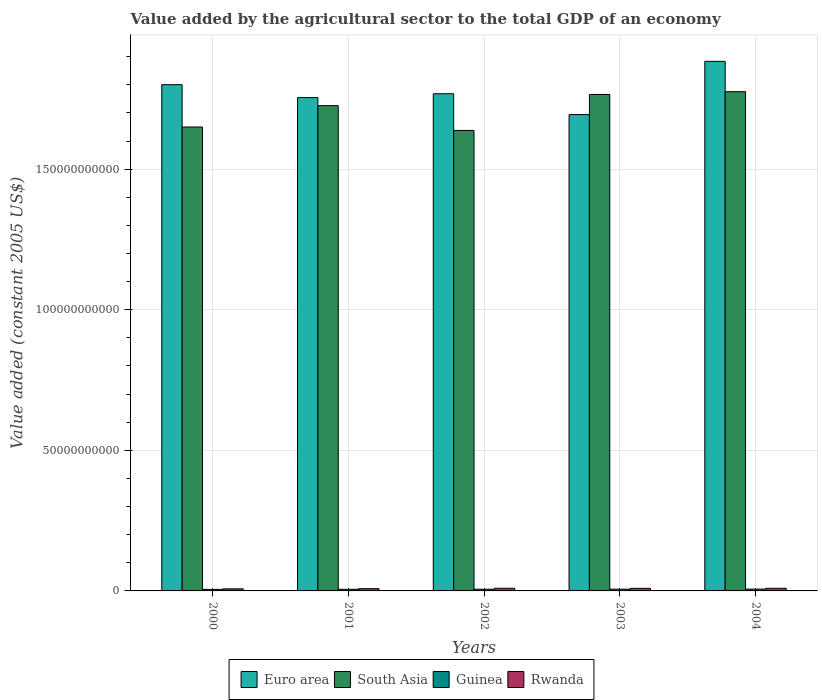How many different coloured bars are there?
Make the answer very short. 4. How many groups of bars are there?
Give a very brief answer. 5. Are the number of bars per tick equal to the number of legend labels?
Your response must be concise. Yes. Are the number of bars on each tick of the X-axis equal?
Give a very brief answer. Yes. What is the label of the 5th group of bars from the left?
Provide a short and direct response. 2004. What is the value added by the agricultural sector in Rwanda in 2004?
Provide a succinct answer. 9.32e+08. Across all years, what is the maximum value added by the agricultural sector in Rwanda?
Keep it short and to the point. 9.40e+08. Across all years, what is the minimum value added by the agricultural sector in South Asia?
Offer a terse response. 1.64e+11. In which year was the value added by the agricultural sector in Guinea maximum?
Offer a very short reply. 2004. In which year was the value added by the agricultural sector in Rwanda minimum?
Provide a short and direct response. 2000. What is the total value added by the agricultural sector in South Asia in the graph?
Your answer should be compact. 8.55e+11. What is the difference between the value added by the agricultural sector in Rwanda in 2003 and that in 2004?
Make the answer very short. -1.91e+07. What is the difference between the value added by the agricultural sector in South Asia in 2000 and the value added by the agricultural sector in Guinea in 2003?
Offer a very short reply. 1.64e+11. What is the average value added by the agricultural sector in Guinea per year?
Make the answer very short. 6.01e+08. In the year 2002, what is the difference between the value added by the agricultural sector in Rwanda and value added by the agricultural sector in Euro area?
Offer a terse response. -1.76e+11. What is the ratio of the value added by the agricultural sector in Euro area in 2000 to that in 2002?
Provide a succinct answer. 1.02. Is the value added by the agricultural sector in Guinea in 2002 less than that in 2004?
Your answer should be very brief. Yes. What is the difference between the highest and the second highest value added by the agricultural sector in Rwanda?
Offer a very short reply. 7.75e+06. What is the difference between the highest and the lowest value added by the agricultural sector in Euro area?
Give a very brief answer. 1.89e+1. In how many years, is the value added by the agricultural sector in Rwanda greater than the average value added by the agricultural sector in Rwanda taken over all years?
Provide a succinct answer. 3. What does the 1st bar from the left in 2003 represents?
Offer a terse response. Euro area. What does the 4th bar from the right in 2000 represents?
Offer a terse response. Euro area. Is it the case that in every year, the sum of the value added by the agricultural sector in Guinea and value added by the agricultural sector in Rwanda is greater than the value added by the agricultural sector in South Asia?
Give a very brief answer. No. How many bars are there?
Your answer should be very brief. 20. Are all the bars in the graph horizontal?
Provide a succinct answer. No. What is the difference between two consecutive major ticks on the Y-axis?
Your answer should be very brief. 5.00e+1. Does the graph contain grids?
Your answer should be compact. Yes. How are the legend labels stacked?
Provide a succinct answer. Horizontal. What is the title of the graph?
Offer a terse response. Value added by the agricultural sector to the total GDP of an economy. Does "Guyana" appear as one of the legend labels in the graph?
Your response must be concise. No. What is the label or title of the X-axis?
Keep it short and to the point. Years. What is the label or title of the Y-axis?
Ensure brevity in your answer.  Value added (constant 2005 US$). What is the Value added (constant 2005 US$) of Euro area in 2000?
Provide a short and direct response. 1.80e+11. What is the Value added (constant 2005 US$) in South Asia in 2000?
Your response must be concise. 1.65e+11. What is the Value added (constant 2005 US$) of Guinea in 2000?
Provide a succinct answer. 5.48e+08. What is the Value added (constant 2005 US$) of Rwanda in 2000?
Provide a succinct answer. 7.39e+08. What is the Value added (constant 2005 US$) in Euro area in 2001?
Provide a short and direct response. 1.75e+11. What is the Value added (constant 2005 US$) of South Asia in 2001?
Provide a short and direct response. 1.73e+11. What is the Value added (constant 2005 US$) in Guinea in 2001?
Keep it short and to the point. 5.80e+08. What is the Value added (constant 2005 US$) of Rwanda in 2001?
Provide a short and direct response. 8.04e+08. What is the Value added (constant 2005 US$) of Euro area in 2002?
Give a very brief answer. 1.77e+11. What is the Value added (constant 2005 US$) of South Asia in 2002?
Ensure brevity in your answer.  1.64e+11. What is the Value added (constant 2005 US$) in Guinea in 2002?
Your response must be concise. 6.04e+08. What is the Value added (constant 2005 US$) of Rwanda in 2002?
Provide a succinct answer. 9.40e+08. What is the Value added (constant 2005 US$) of Euro area in 2003?
Your answer should be compact. 1.69e+11. What is the Value added (constant 2005 US$) of South Asia in 2003?
Keep it short and to the point. 1.77e+11. What is the Value added (constant 2005 US$) of Guinea in 2003?
Keep it short and to the point. 6.26e+08. What is the Value added (constant 2005 US$) of Rwanda in 2003?
Provide a succinct answer. 9.13e+08. What is the Value added (constant 2005 US$) of Euro area in 2004?
Offer a terse response. 1.88e+11. What is the Value added (constant 2005 US$) in South Asia in 2004?
Provide a short and direct response. 1.78e+11. What is the Value added (constant 2005 US$) in Guinea in 2004?
Offer a very short reply. 6.46e+08. What is the Value added (constant 2005 US$) in Rwanda in 2004?
Provide a short and direct response. 9.32e+08. Across all years, what is the maximum Value added (constant 2005 US$) of Euro area?
Make the answer very short. 1.88e+11. Across all years, what is the maximum Value added (constant 2005 US$) in South Asia?
Provide a short and direct response. 1.78e+11. Across all years, what is the maximum Value added (constant 2005 US$) of Guinea?
Offer a very short reply. 6.46e+08. Across all years, what is the maximum Value added (constant 2005 US$) of Rwanda?
Keep it short and to the point. 9.40e+08. Across all years, what is the minimum Value added (constant 2005 US$) in Euro area?
Provide a succinct answer. 1.69e+11. Across all years, what is the minimum Value added (constant 2005 US$) of South Asia?
Keep it short and to the point. 1.64e+11. Across all years, what is the minimum Value added (constant 2005 US$) in Guinea?
Provide a succinct answer. 5.48e+08. Across all years, what is the minimum Value added (constant 2005 US$) in Rwanda?
Offer a terse response. 7.39e+08. What is the total Value added (constant 2005 US$) in Euro area in the graph?
Provide a succinct answer. 8.90e+11. What is the total Value added (constant 2005 US$) in South Asia in the graph?
Your answer should be compact. 8.55e+11. What is the total Value added (constant 2005 US$) of Guinea in the graph?
Provide a short and direct response. 3.00e+09. What is the total Value added (constant 2005 US$) of Rwanda in the graph?
Provide a succinct answer. 4.33e+09. What is the difference between the Value added (constant 2005 US$) of Euro area in 2000 and that in 2001?
Your response must be concise. 4.59e+09. What is the difference between the Value added (constant 2005 US$) in South Asia in 2000 and that in 2001?
Give a very brief answer. -7.59e+09. What is the difference between the Value added (constant 2005 US$) in Guinea in 2000 and that in 2001?
Your answer should be very brief. -3.24e+07. What is the difference between the Value added (constant 2005 US$) in Rwanda in 2000 and that in 2001?
Your response must be concise. -6.52e+07. What is the difference between the Value added (constant 2005 US$) in Euro area in 2000 and that in 2002?
Keep it short and to the point. 3.23e+09. What is the difference between the Value added (constant 2005 US$) in South Asia in 2000 and that in 2002?
Your response must be concise. 1.23e+09. What is the difference between the Value added (constant 2005 US$) in Guinea in 2000 and that in 2002?
Provide a short and direct response. -5.69e+07. What is the difference between the Value added (constant 2005 US$) in Rwanda in 2000 and that in 2002?
Offer a terse response. -2.01e+08. What is the difference between the Value added (constant 2005 US$) in Euro area in 2000 and that in 2003?
Your answer should be compact. 1.06e+1. What is the difference between the Value added (constant 2005 US$) in South Asia in 2000 and that in 2003?
Provide a short and direct response. -1.16e+1. What is the difference between the Value added (constant 2005 US$) of Guinea in 2000 and that in 2003?
Ensure brevity in your answer.  -7.82e+07. What is the difference between the Value added (constant 2005 US$) of Rwanda in 2000 and that in 2003?
Keep it short and to the point. -1.74e+08. What is the difference between the Value added (constant 2005 US$) in Euro area in 2000 and that in 2004?
Provide a succinct answer. -8.30e+09. What is the difference between the Value added (constant 2005 US$) in South Asia in 2000 and that in 2004?
Give a very brief answer. -1.26e+1. What is the difference between the Value added (constant 2005 US$) of Guinea in 2000 and that in 2004?
Provide a short and direct response. -9.82e+07. What is the difference between the Value added (constant 2005 US$) in Rwanda in 2000 and that in 2004?
Offer a terse response. -1.93e+08. What is the difference between the Value added (constant 2005 US$) in Euro area in 2001 and that in 2002?
Your answer should be very brief. -1.37e+09. What is the difference between the Value added (constant 2005 US$) in South Asia in 2001 and that in 2002?
Make the answer very short. 8.82e+09. What is the difference between the Value added (constant 2005 US$) of Guinea in 2001 and that in 2002?
Offer a very short reply. -2.44e+07. What is the difference between the Value added (constant 2005 US$) of Rwanda in 2001 and that in 2002?
Your answer should be compact. -1.35e+08. What is the difference between the Value added (constant 2005 US$) of Euro area in 2001 and that in 2003?
Your response must be concise. 6.04e+09. What is the difference between the Value added (constant 2005 US$) in South Asia in 2001 and that in 2003?
Offer a very short reply. -3.98e+09. What is the difference between the Value added (constant 2005 US$) of Guinea in 2001 and that in 2003?
Keep it short and to the point. -4.57e+07. What is the difference between the Value added (constant 2005 US$) in Rwanda in 2001 and that in 2003?
Your answer should be very brief. -1.09e+08. What is the difference between the Value added (constant 2005 US$) in Euro area in 2001 and that in 2004?
Ensure brevity in your answer.  -1.29e+1. What is the difference between the Value added (constant 2005 US$) in South Asia in 2001 and that in 2004?
Your answer should be very brief. -4.97e+09. What is the difference between the Value added (constant 2005 US$) in Guinea in 2001 and that in 2004?
Your response must be concise. -6.58e+07. What is the difference between the Value added (constant 2005 US$) in Rwanda in 2001 and that in 2004?
Provide a short and direct response. -1.28e+08. What is the difference between the Value added (constant 2005 US$) of Euro area in 2002 and that in 2003?
Give a very brief answer. 7.41e+09. What is the difference between the Value added (constant 2005 US$) of South Asia in 2002 and that in 2003?
Provide a short and direct response. -1.28e+1. What is the difference between the Value added (constant 2005 US$) in Guinea in 2002 and that in 2003?
Provide a succinct answer. -2.13e+07. What is the difference between the Value added (constant 2005 US$) in Rwanda in 2002 and that in 2003?
Your answer should be very brief. 2.68e+07. What is the difference between the Value added (constant 2005 US$) in Euro area in 2002 and that in 2004?
Your response must be concise. -1.15e+1. What is the difference between the Value added (constant 2005 US$) in South Asia in 2002 and that in 2004?
Make the answer very short. -1.38e+1. What is the difference between the Value added (constant 2005 US$) in Guinea in 2002 and that in 2004?
Your answer should be compact. -4.14e+07. What is the difference between the Value added (constant 2005 US$) in Rwanda in 2002 and that in 2004?
Make the answer very short. 7.75e+06. What is the difference between the Value added (constant 2005 US$) of Euro area in 2003 and that in 2004?
Offer a very short reply. -1.89e+1. What is the difference between the Value added (constant 2005 US$) of South Asia in 2003 and that in 2004?
Keep it short and to the point. -9.88e+08. What is the difference between the Value added (constant 2005 US$) of Guinea in 2003 and that in 2004?
Make the answer very short. -2.01e+07. What is the difference between the Value added (constant 2005 US$) of Rwanda in 2003 and that in 2004?
Your answer should be very brief. -1.91e+07. What is the difference between the Value added (constant 2005 US$) in Euro area in 2000 and the Value added (constant 2005 US$) in South Asia in 2001?
Your answer should be compact. 7.46e+09. What is the difference between the Value added (constant 2005 US$) in Euro area in 2000 and the Value added (constant 2005 US$) in Guinea in 2001?
Give a very brief answer. 1.79e+11. What is the difference between the Value added (constant 2005 US$) of Euro area in 2000 and the Value added (constant 2005 US$) of Rwanda in 2001?
Offer a terse response. 1.79e+11. What is the difference between the Value added (constant 2005 US$) of South Asia in 2000 and the Value added (constant 2005 US$) of Guinea in 2001?
Give a very brief answer. 1.64e+11. What is the difference between the Value added (constant 2005 US$) of South Asia in 2000 and the Value added (constant 2005 US$) of Rwanda in 2001?
Your answer should be very brief. 1.64e+11. What is the difference between the Value added (constant 2005 US$) of Guinea in 2000 and the Value added (constant 2005 US$) of Rwanda in 2001?
Your answer should be compact. -2.57e+08. What is the difference between the Value added (constant 2005 US$) in Euro area in 2000 and the Value added (constant 2005 US$) in South Asia in 2002?
Make the answer very short. 1.63e+1. What is the difference between the Value added (constant 2005 US$) of Euro area in 2000 and the Value added (constant 2005 US$) of Guinea in 2002?
Give a very brief answer. 1.79e+11. What is the difference between the Value added (constant 2005 US$) in Euro area in 2000 and the Value added (constant 2005 US$) in Rwanda in 2002?
Provide a short and direct response. 1.79e+11. What is the difference between the Value added (constant 2005 US$) in South Asia in 2000 and the Value added (constant 2005 US$) in Guinea in 2002?
Ensure brevity in your answer.  1.64e+11. What is the difference between the Value added (constant 2005 US$) in South Asia in 2000 and the Value added (constant 2005 US$) in Rwanda in 2002?
Keep it short and to the point. 1.64e+11. What is the difference between the Value added (constant 2005 US$) of Guinea in 2000 and the Value added (constant 2005 US$) of Rwanda in 2002?
Give a very brief answer. -3.92e+08. What is the difference between the Value added (constant 2005 US$) in Euro area in 2000 and the Value added (constant 2005 US$) in South Asia in 2003?
Your answer should be very brief. 3.47e+09. What is the difference between the Value added (constant 2005 US$) of Euro area in 2000 and the Value added (constant 2005 US$) of Guinea in 2003?
Provide a short and direct response. 1.79e+11. What is the difference between the Value added (constant 2005 US$) of Euro area in 2000 and the Value added (constant 2005 US$) of Rwanda in 2003?
Make the answer very short. 1.79e+11. What is the difference between the Value added (constant 2005 US$) of South Asia in 2000 and the Value added (constant 2005 US$) of Guinea in 2003?
Your answer should be compact. 1.64e+11. What is the difference between the Value added (constant 2005 US$) of South Asia in 2000 and the Value added (constant 2005 US$) of Rwanda in 2003?
Provide a succinct answer. 1.64e+11. What is the difference between the Value added (constant 2005 US$) in Guinea in 2000 and the Value added (constant 2005 US$) in Rwanda in 2003?
Your answer should be very brief. -3.65e+08. What is the difference between the Value added (constant 2005 US$) in Euro area in 2000 and the Value added (constant 2005 US$) in South Asia in 2004?
Offer a terse response. 2.49e+09. What is the difference between the Value added (constant 2005 US$) of Euro area in 2000 and the Value added (constant 2005 US$) of Guinea in 2004?
Your response must be concise. 1.79e+11. What is the difference between the Value added (constant 2005 US$) in Euro area in 2000 and the Value added (constant 2005 US$) in Rwanda in 2004?
Provide a short and direct response. 1.79e+11. What is the difference between the Value added (constant 2005 US$) of South Asia in 2000 and the Value added (constant 2005 US$) of Guinea in 2004?
Offer a very short reply. 1.64e+11. What is the difference between the Value added (constant 2005 US$) in South Asia in 2000 and the Value added (constant 2005 US$) in Rwanda in 2004?
Your response must be concise. 1.64e+11. What is the difference between the Value added (constant 2005 US$) in Guinea in 2000 and the Value added (constant 2005 US$) in Rwanda in 2004?
Keep it short and to the point. -3.84e+08. What is the difference between the Value added (constant 2005 US$) of Euro area in 2001 and the Value added (constant 2005 US$) of South Asia in 2002?
Ensure brevity in your answer.  1.17e+1. What is the difference between the Value added (constant 2005 US$) in Euro area in 2001 and the Value added (constant 2005 US$) in Guinea in 2002?
Make the answer very short. 1.75e+11. What is the difference between the Value added (constant 2005 US$) in Euro area in 2001 and the Value added (constant 2005 US$) in Rwanda in 2002?
Keep it short and to the point. 1.74e+11. What is the difference between the Value added (constant 2005 US$) in South Asia in 2001 and the Value added (constant 2005 US$) in Guinea in 2002?
Offer a very short reply. 1.72e+11. What is the difference between the Value added (constant 2005 US$) in South Asia in 2001 and the Value added (constant 2005 US$) in Rwanda in 2002?
Your response must be concise. 1.72e+11. What is the difference between the Value added (constant 2005 US$) in Guinea in 2001 and the Value added (constant 2005 US$) in Rwanda in 2002?
Give a very brief answer. -3.60e+08. What is the difference between the Value added (constant 2005 US$) of Euro area in 2001 and the Value added (constant 2005 US$) of South Asia in 2003?
Your answer should be very brief. -1.12e+09. What is the difference between the Value added (constant 2005 US$) of Euro area in 2001 and the Value added (constant 2005 US$) of Guinea in 2003?
Your response must be concise. 1.75e+11. What is the difference between the Value added (constant 2005 US$) in Euro area in 2001 and the Value added (constant 2005 US$) in Rwanda in 2003?
Your response must be concise. 1.75e+11. What is the difference between the Value added (constant 2005 US$) of South Asia in 2001 and the Value added (constant 2005 US$) of Guinea in 2003?
Ensure brevity in your answer.  1.72e+11. What is the difference between the Value added (constant 2005 US$) in South Asia in 2001 and the Value added (constant 2005 US$) in Rwanda in 2003?
Provide a succinct answer. 1.72e+11. What is the difference between the Value added (constant 2005 US$) in Guinea in 2001 and the Value added (constant 2005 US$) in Rwanda in 2003?
Ensure brevity in your answer.  -3.33e+08. What is the difference between the Value added (constant 2005 US$) in Euro area in 2001 and the Value added (constant 2005 US$) in South Asia in 2004?
Your response must be concise. -2.11e+09. What is the difference between the Value added (constant 2005 US$) of Euro area in 2001 and the Value added (constant 2005 US$) of Guinea in 2004?
Your response must be concise. 1.75e+11. What is the difference between the Value added (constant 2005 US$) in Euro area in 2001 and the Value added (constant 2005 US$) in Rwanda in 2004?
Offer a terse response. 1.75e+11. What is the difference between the Value added (constant 2005 US$) in South Asia in 2001 and the Value added (constant 2005 US$) in Guinea in 2004?
Keep it short and to the point. 1.72e+11. What is the difference between the Value added (constant 2005 US$) of South Asia in 2001 and the Value added (constant 2005 US$) of Rwanda in 2004?
Your answer should be very brief. 1.72e+11. What is the difference between the Value added (constant 2005 US$) of Guinea in 2001 and the Value added (constant 2005 US$) of Rwanda in 2004?
Offer a very short reply. -3.52e+08. What is the difference between the Value added (constant 2005 US$) in Euro area in 2002 and the Value added (constant 2005 US$) in South Asia in 2003?
Provide a succinct answer. 2.49e+08. What is the difference between the Value added (constant 2005 US$) in Euro area in 2002 and the Value added (constant 2005 US$) in Guinea in 2003?
Give a very brief answer. 1.76e+11. What is the difference between the Value added (constant 2005 US$) in Euro area in 2002 and the Value added (constant 2005 US$) in Rwanda in 2003?
Keep it short and to the point. 1.76e+11. What is the difference between the Value added (constant 2005 US$) in South Asia in 2002 and the Value added (constant 2005 US$) in Guinea in 2003?
Ensure brevity in your answer.  1.63e+11. What is the difference between the Value added (constant 2005 US$) in South Asia in 2002 and the Value added (constant 2005 US$) in Rwanda in 2003?
Your answer should be compact. 1.63e+11. What is the difference between the Value added (constant 2005 US$) in Guinea in 2002 and the Value added (constant 2005 US$) in Rwanda in 2003?
Your response must be concise. -3.08e+08. What is the difference between the Value added (constant 2005 US$) in Euro area in 2002 and the Value added (constant 2005 US$) in South Asia in 2004?
Give a very brief answer. -7.39e+08. What is the difference between the Value added (constant 2005 US$) of Euro area in 2002 and the Value added (constant 2005 US$) of Guinea in 2004?
Provide a short and direct response. 1.76e+11. What is the difference between the Value added (constant 2005 US$) of Euro area in 2002 and the Value added (constant 2005 US$) of Rwanda in 2004?
Provide a succinct answer. 1.76e+11. What is the difference between the Value added (constant 2005 US$) of South Asia in 2002 and the Value added (constant 2005 US$) of Guinea in 2004?
Your response must be concise. 1.63e+11. What is the difference between the Value added (constant 2005 US$) of South Asia in 2002 and the Value added (constant 2005 US$) of Rwanda in 2004?
Offer a very short reply. 1.63e+11. What is the difference between the Value added (constant 2005 US$) in Guinea in 2002 and the Value added (constant 2005 US$) in Rwanda in 2004?
Ensure brevity in your answer.  -3.27e+08. What is the difference between the Value added (constant 2005 US$) of Euro area in 2003 and the Value added (constant 2005 US$) of South Asia in 2004?
Your answer should be very brief. -8.15e+09. What is the difference between the Value added (constant 2005 US$) of Euro area in 2003 and the Value added (constant 2005 US$) of Guinea in 2004?
Give a very brief answer. 1.69e+11. What is the difference between the Value added (constant 2005 US$) in Euro area in 2003 and the Value added (constant 2005 US$) in Rwanda in 2004?
Offer a very short reply. 1.68e+11. What is the difference between the Value added (constant 2005 US$) of South Asia in 2003 and the Value added (constant 2005 US$) of Guinea in 2004?
Keep it short and to the point. 1.76e+11. What is the difference between the Value added (constant 2005 US$) of South Asia in 2003 and the Value added (constant 2005 US$) of Rwanda in 2004?
Provide a short and direct response. 1.76e+11. What is the difference between the Value added (constant 2005 US$) in Guinea in 2003 and the Value added (constant 2005 US$) in Rwanda in 2004?
Give a very brief answer. -3.06e+08. What is the average Value added (constant 2005 US$) of Euro area per year?
Your answer should be compact. 1.78e+11. What is the average Value added (constant 2005 US$) of South Asia per year?
Offer a terse response. 1.71e+11. What is the average Value added (constant 2005 US$) in Guinea per year?
Your response must be concise. 6.01e+08. What is the average Value added (constant 2005 US$) in Rwanda per year?
Provide a short and direct response. 8.65e+08. In the year 2000, what is the difference between the Value added (constant 2005 US$) of Euro area and Value added (constant 2005 US$) of South Asia?
Your response must be concise. 1.50e+1. In the year 2000, what is the difference between the Value added (constant 2005 US$) in Euro area and Value added (constant 2005 US$) in Guinea?
Offer a very short reply. 1.79e+11. In the year 2000, what is the difference between the Value added (constant 2005 US$) in Euro area and Value added (constant 2005 US$) in Rwanda?
Your answer should be compact. 1.79e+11. In the year 2000, what is the difference between the Value added (constant 2005 US$) of South Asia and Value added (constant 2005 US$) of Guinea?
Make the answer very short. 1.64e+11. In the year 2000, what is the difference between the Value added (constant 2005 US$) of South Asia and Value added (constant 2005 US$) of Rwanda?
Your response must be concise. 1.64e+11. In the year 2000, what is the difference between the Value added (constant 2005 US$) of Guinea and Value added (constant 2005 US$) of Rwanda?
Make the answer very short. -1.91e+08. In the year 2001, what is the difference between the Value added (constant 2005 US$) of Euro area and Value added (constant 2005 US$) of South Asia?
Keep it short and to the point. 2.86e+09. In the year 2001, what is the difference between the Value added (constant 2005 US$) in Euro area and Value added (constant 2005 US$) in Guinea?
Offer a terse response. 1.75e+11. In the year 2001, what is the difference between the Value added (constant 2005 US$) of Euro area and Value added (constant 2005 US$) of Rwanda?
Make the answer very short. 1.75e+11. In the year 2001, what is the difference between the Value added (constant 2005 US$) in South Asia and Value added (constant 2005 US$) in Guinea?
Ensure brevity in your answer.  1.72e+11. In the year 2001, what is the difference between the Value added (constant 2005 US$) in South Asia and Value added (constant 2005 US$) in Rwanda?
Make the answer very short. 1.72e+11. In the year 2001, what is the difference between the Value added (constant 2005 US$) of Guinea and Value added (constant 2005 US$) of Rwanda?
Provide a succinct answer. -2.24e+08. In the year 2002, what is the difference between the Value added (constant 2005 US$) in Euro area and Value added (constant 2005 US$) in South Asia?
Your answer should be compact. 1.30e+1. In the year 2002, what is the difference between the Value added (constant 2005 US$) in Euro area and Value added (constant 2005 US$) in Guinea?
Provide a succinct answer. 1.76e+11. In the year 2002, what is the difference between the Value added (constant 2005 US$) in Euro area and Value added (constant 2005 US$) in Rwanda?
Your response must be concise. 1.76e+11. In the year 2002, what is the difference between the Value added (constant 2005 US$) in South Asia and Value added (constant 2005 US$) in Guinea?
Make the answer very short. 1.63e+11. In the year 2002, what is the difference between the Value added (constant 2005 US$) in South Asia and Value added (constant 2005 US$) in Rwanda?
Your answer should be compact. 1.63e+11. In the year 2002, what is the difference between the Value added (constant 2005 US$) in Guinea and Value added (constant 2005 US$) in Rwanda?
Your answer should be compact. -3.35e+08. In the year 2003, what is the difference between the Value added (constant 2005 US$) of Euro area and Value added (constant 2005 US$) of South Asia?
Offer a terse response. -7.16e+09. In the year 2003, what is the difference between the Value added (constant 2005 US$) of Euro area and Value added (constant 2005 US$) of Guinea?
Ensure brevity in your answer.  1.69e+11. In the year 2003, what is the difference between the Value added (constant 2005 US$) of Euro area and Value added (constant 2005 US$) of Rwanda?
Provide a short and direct response. 1.68e+11. In the year 2003, what is the difference between the Value added (constant 2005 US$) of South Asia and Value added (constant 2005 US$) of Guinea?
Give a very brief answer. 1.76e+11. In the year 2003, what is the difference between the Value added (constant 2005 US$) of South Asia and Value added (constant 2005 US$) of Rwanda?
Your answer should be very brief. 1.76e+11. In the year 2003, what is the difference between the Value added (constant 2005 US$) of Guinea and Value added (constant 2005 US$) of Rwanda?
Make the answer very short. -2.87e+08. In the year 2004, what is the difference between the Value added (constant 2005 US$) in Euro area and Value added (constant 2005 US$) in South Asia?
Offer a terse response. 1.08e+1. In the year 2004, what is the difference between the Value added (constant 2005 US$) in Euro area and Value added (constant 2005 US$) in Guinea?
Provide a succinct answer. 1.88e+11. In the year 2004, what is the difference between the Value added (constant 2005 US$) in Euro area and Value added (constant 2005 US$) in Rwanda?
Offer a terse response. 1.87e+11. In the year 2004, what is the difference between the Value added (constant 2005 US$) in South Asia and Value added (constant 2005 US$) in Guinea?
Your response must be concise. 1.77e+11. In the year 2004, what is the difference between the Value added (constant 2005 US$) in South Asia and Value added (constant 2005 US$) in Rwanda?
Give a very brief answer. 1.77e+11. In the year 2004, what is the difference between the Value added (constant 2005 US$) of Guinea and Value added (constant 2005 US$) of Rwanda?
Your response must be concise. -2.86e+08. What is the ratio of the Value added (constant 2005 US$) in Euro area in 2000 to that in 2001?
Make the answer very short. 1.03. What is the ratio of the Value added (constant 2005 US$) of South Asia in 2000 to that in 2001?
Keep it short and to the point. 0.96. What is the ratio of the Value added (constant 2005 US$) of Guinea in 2000 to that in 2001?
Offer a very short reply. 0.94. What is the ratio of the Value added (constant 2005 US$) in Rwanda in 2000 to that in 2001?
Your answer should be very brief. 0.92. What is the ratio of the Value added (constant 2005 US$) of Euro area in 2000 to that in 2002?
Offer a very short reply. 1.02. What is the ratio of the Value added (constant 2005 US$) in South Asia in 2000 to that in 2002?
Offer a very short reply. 1.01. What is the ratio of the Value added (constant 2005 US$) in Guinea in 2000 to that in 2002?
Provide a succinct answer. 0.91. What is the ratio of the Value added (constant 2005 US$) in Rwanda in 2000 to that in 2002?
Make the answer very short. 0.79. What is the ratio of the Value added (constant 2005 US$) of Euro area in 2000 to that in 2003?
Offer a very short reply. 1.06. What is the ratio of the Value added (constant 2005 US$) in South Asia in 2000 to that in 2003?
Keep it short and to the point. 0.93. What is the ratio of the Value added (constant 2005 US$) in Guinea in 2000 to that in 2003?
Offer a very short reply. 0.88. What is the ratio of the Value added (constant 2005 US$) in Rwanda in 2000 to that in 2003?
Give a very brief answer. 0.81. What is the ratio of the Value added (constant 2005 US$) in Euro area in 2000 to that in 2004?
Ensure brevity in your answer.  0.96. What is the ratio of the Value added (constant 2005 US$) in South Asia in 2000 to that in 2004?
Ensure brevity in your answer.  0.93. What is the ratio of the Value added (constant 2005 US$) in Guinea in 2000 to that in 2004?
Give a very brief answer. 0.85. What is the ratio of the Value added (constant 2005 US$) of Rwanda in 2000 to that in 2004?
Your answer should be compact. 0.79. What is the ratio of the Value added (constant 2005 US$) of South Asia in 2001 to that in 2002?
Your response must be concise. 1.05. What is the ratio of the Value added (constant 2005 US$) of Guinea in 2001 to that in 2002?
Your response must be concise. 0.96. What is the ratio of the Value added (constant 2005 US$) of Rwanda in 2001 to that in 2002?
Your response must be concise. 0.86. What is the ratio of the Value added (constant 2005 US$) in Euro area in 2001 to that in 2003?
Your answer should be compact. 1.04. What is the ratio of the Value added (constant 2005 US$) in South Asia in 2001 to that in 2003?
Your response must be concise. 0.98. What is the ratio of the Value added (constant 2005 US$) of Guinea in 2001 to that in 2003?
Provide a short and direct response. 0.93. What is the ratio of the Value added (constant 2005 US$) of Rwanda in 2001 to that in 2003?
Ensure brevity in your answer.  0.88. What is the ratio of the Value added (constant 2005 US$) in Euro area in 2001 to that in 2004?
Give a very brief answer. 0.93. What is the ratio of the Value added (constant 2005 US$) of South Asia in 2001 to that in 2004?
Give a very brief answer. 0.97. What is the ratio of the Value added (constant 2005 US$) in Guinea in 2001 to that in 2004?
Provide a succinct answer. 0.9. What is the ratio of the Value added (constant 2005 US$) in Rwanda in 2001 to that in 2004?
Give a very brief answer. 0.86. What is the ratio of the Value added (constant 2005 US$) of Euro area in 2002 to that in 2003?
Ensure brevity in your answer.  1.04. What is the ratio of the Value added (constant 2005 US$) of South Asia in 2002 to that in 2003?
Provide a short and direct response. 0.93. What is the ratio of the Value added (constant 2005 US$) of Guinea in 2002 to that in 2003?
Your answer should be compact. 0.97. What is the ratio of the Value added (constant 2005 US$) of Rwanda in 2002 to that in 2003?
Offer a very short reply. 1.03. What is the ratio of the Value added (constant 2005 US$) in Euro area in 2002 to that in 2004?
Give a very brief answer. 0.94. What is the ratio of the Value added (constant 2005 US$) of South Asia in 2002 to that in 2004?
Your response must be concise. 0.92. What is the ratio of the Value added (constant 2005 US$) of Guinea in 2002 to that in 2004?
Keep it short and to the point. 0.94. What is the ratio of the Value added (constant 2005 US$) in Rwanda in 2002 to that in 2004?
Offer a very short reply. 1.01. What is the ratio of the Value added (constant 2005 US$) in Euro area in 2003 to that in 2004?
Your answer should be compact. 0.9. What is the ratio of the Value added (constant 2005 US$) of Guinea in 2003 to that in 2004?
Provide a short and direct response. 0.97. What is the ratio of the Value added (constant 2005 US$) in Rwanda in 2003 to that in 2004?
Your response must be concise. 0.98. What is the difference between the highest and the second highest Value added (constant 2005 US$) of Euro area?
Your response must be concise. 8.30e+09. What is the difference between the highest and the second highest Value added (constant 2005 US$) of South Asia?
Your response must be concise. 9.88e+08. What is the difference between the highest and the second highest Value added (constant 2005 US$) of Guinea?
Your answer should be very brief. 2.01e+07. What is the difference between the highest and the second highest Value added (constant 2005 US$) of Rwanda?
Your response must be concise. 7.75e+06. What is the difference between the highest and the lowest Value added (constant 2005 US$) of Euro area?
Provide a short and direct response. 1.89e+1. What is the difference between the highest and the lowest Value added (constant 2005 US$) in South Asia?
Ensure brevity in your answer.  1.38e+1. What is the difference between the highest and the lowest Value added (constant 2005 US$) in Guinea?
Your answer should be compact. 9.82e+07. What is the difference between the highest and the lowest Value added (constant 2005 US$) in Rwanda?
Provide a short and direct response. 2.01e+08. 